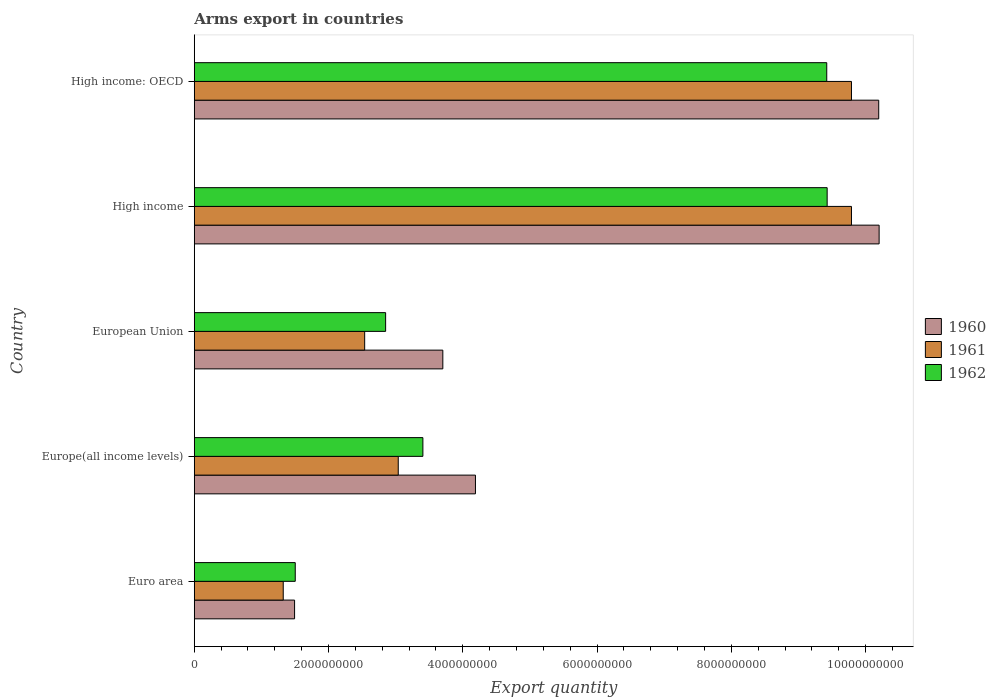How many groups of bars are there?
Your response must be concise. 5. In how many cases, is the number of bars for a given country not equal to the number of legend labels?
Make the answer very short. 0. What is the total arms export in 1961 in Euro area?
Offer a terse response. 1.32e+09. Across all countries, what is the maximum total arms export in 1962?
Provide a short and direct response. 9.43e+09. Across all countries, what is the minimum total arms export in 1962?
Keep it short and to the point. 1.50e+09. In which country was the total arms export in 1962 maximum?
Your answer should be very brief. High income. What is the total total arms export in 1962 in the graph?
Provide a succinct answer. 2.66e+1. What is the difference between the total arms export in 1961 in Europe(all income levels) and that in High income?
Make the answer very short. -6.75e+09. What is the difference between the total arms export in 1961 in High income: OECD and the total arms export in 1960 in Europe(all income levels)?
Give a very brief answer. 5.60e+09. What is the average total arms export in 1960 per country?
Your response must be concise. 5.96e+09. What is the difference between the total arms export in 1960 and total arms export in 1962 in European Union?
Offer a terse response. 8.52e+08. What is the ratio of the total arms export in 1962 in Euro area to that in Europe(all income levels)?
Give a very brief answer. 0.44. What is the difference between the highest and the lowest total arms export in 1962?
Your answer should be very brief. 7.92e+09. In how many countries, is the total arms export in 1962 greater than the average total arms export in 1962 taken over all countries?
Offer a terse response. 2. How many bars are there?
Ensure brevity in your answer.  15. Are the values on the major ticks of X-axis written in scientific E-notation?
Provide a short and direct response. No. Does the graph contain grids?
Provide a succinct answer. No. What is the title of the graph?
Make the answer very short. Arms export in countries. What is the label or title of the X-axis?
Provide a short and direct response. Export quantity. What is the label or title of the Y-axis?
Your answer should be very brief. Country. What is the Export quantity of 1960 in Euro area?
Your answer should be compact. 1.49e+09. What is the Export quantity in 1961 in Euro area?
Your answer should be very brief. 1.32e+09. What is the Export quantity in 1962 in Euro area?
Offer a terse response. 1.50e+09. What is the Export quantity in 1960 in Europe(all income levels)?
Provide a succinct answer. 4.19e+09. What is the Export quantity in 1961 in Europe(all income levels)?
Give a very brief answer. 3.04e+09. What is the Export quantity in 1962 in Europe(all income levels)?
Offer a terse response. 3.40e+09. What is the Export quantity in 1960 in European Union?
Provide a succinct answer. 3.70e+09. What is the Export quantity of 1961 in European Union?
Your response must be concise. 2.54e+09. What is the Export quantity of 1962 in European Union?
Give a very brief answer. 2.85e+09. What is the Export quantity of 1960 in High income?
Give a very brief answer. 1.02e+1. What is the Export quantity of 1961 in High income?
Provide a short and direct response. 9.79e+09. What is the Export quantity of 1962 in High income?
Make the answer very short. 9.43e+09. What is the Export quantity in 1960 in High income: OECD?
Your answer should be very brief. 1.02e+1. What is the Export quantity of 1961 in High income: OECD?
Keep it short and to the point. 9.79e+09. What is the Export quantity in 1962 in High income: OECD?
Make the answer very short. 9.42e+09. Across all countries, what is the maximum Export quantity of 1960?
Make the answer very short. 1.02e+1. Across all countries, what is the maximum Export quantity of 1961?
Make the answer very short. 9.79e+09. Across all countries, what is the maximum Export quantity in 1962?
Your response must be concise. 9.43e+09. Across all countries, what is the minimum Export quantity of 1960?
Make the answer very short. 1.49e+09. Across all countries, what is the minimum Export quantity of 1961?
Your response must be concise. 1.32e+09. Across all countries, what is the minimum Export quantity of 1962?
Provide a short and direct response. 1.50e+09. What is the total Export quantity of 1960 in the graph?
Offer a terse response. 2.98e+1. What is the total Export quantity of 1961 in the graph?
Provide a short and direct response. 2.65e+1. What is the total Export quantity in 1962 in the graph?
Offer a terse response. 2.66e+1. What is the difference between the Export quantity of 1960 in Euro area and that in Europe(all income levels)?
Make the answer very short. -2.69e+09. What is the difference between the Export quantity in 1961 in Euro area and that in Europe(all income levels)?
Give a very brief answer. -1.71e+09. What is the difference between the Export quantity of 1962 in Euro area and that in Europe(all income levels)?
Offer a terse response. -1.90e+09. What is the difference between the Export quantity in 1960 in Euro area and that in European Union?
Give a very brief answer. -2.21e+09. What is the difference between the Export quantity in 1961 in Euro area and that in European Union?
Ensure brevity in your answer.  -1.21e+09. What is the difference between the Export quantity of 1962 in Euro area and that in European Union?
Give a very brief answer. -1.35e+09. What is the difference between the Export quantity in 1960 in Euro area and that in High income?
Make the answer very short. -8.71e+09. What is the difference between the Export quantity of 1961 in Euro area and that in High income?
Your answer should be compact. -8.46e+09. What is the difference between the Export quantity in 1962 in Euro area and that in High income?
Your answer should be very brief. -7.92e+09. What is the difference between the Export quantity in 1960 in Euro area and that in High income: OECD?
Ensure brevity in your answer.  -8.70e+09. What is the difference between the Export quantity in 1961 in Euro area and that in High income: OECD?
Keep it short and to the point. -8.46e+09. What is the difference between the Export quantity in 1962 in Euro area and that in High income: OECD?
Your answer should be very brief. -7.92e+09. What is the difference between the Export quantity in 1960 in Europe(all income levels) and that in European Union?
Provide a short and direct response. 4.86e+08. What is the difference between the Export quantity in 1962 in Europe(all income levels) and that in European Union?
Your answer should be very brief. 5.55e+08. What is the difference between the Export quantity in 1960 in Europe(all income levels) and that in High income?
Your answer should be very brief. -6.01e+09. What is the difference between the Export quantity of 1961 in Europe(all income levels) and that in High income?
Your response must be concise. -6.75e+09. What is the difference between the Export quantity of 1962 in Europe(all income levels) and that in High income?
Make the answer very short. -6.02e+09. What is the difference between the Export quantity in 1960 in Europe(all income levels) and that in High income: OECD?
Make the answer very short. -6.01e+09. What is the difference between the Export quantity in 1961 in Europe(all income levels) and that in High income: OECD?
Offer a terse response. -6.75e+09. What is the difference between the Export quantity of 1962 in Europe(all income levels) and that in High income: OECD?
Offer a very short reply. -6.02e+09. What is the difference between the Export quantity of 1960 in European Union and that in High income?
Ensure brevity in your answer.  -6.50e+09. What is the difference between the Export quantity in 1961 in European Union and that in High income?
Make the answer very short. -7.25e+09. What is the difference between the Export quantity in 1962 in European Union and that in High income?
Ensure brevity in your answer.  -6.58e+09. What is the difference between the Export quantity of 1960 in European Union and that in High income: OECD?
Your answer should be very brief. -6.49e+09. What is the difference between the Export quantity of 1961 in European Union and that in High income: OECD?
Ensure brevity in your answer.  -7.25e+09. What is the difference between the Export quantity of 1962 in European Union and that in High income: OECD?
Provide a succinct answer. -6.57e+09. What is the difference between the Export quantity of 1961 in High income and that in High income: OECD?
Provide a short and direct response. 0. What is the difference between the Export quantity of 1962 in High income and that in High income: OECD?
Keep it short and to the point. 6.00e+06. What is the difference between the Export quantity in 1960 in Euro area and the Export quantity in 1961 in Europe(all income levels)?
Provide a short and direct response. -1.54e+09. What is the difference between the Export quantity of 1960 in Euro area and the Export quantity of 1962 in Europe(all income levels)?
Ensure brevity in your answer.  -1.91e+09. What is the difference between the Export quantity of 1961 in Euro area and the Export quantity of 1962 in Europe(all income levels)?
Offer a very short reply. -2.08e+09. What is the difference between the Export quantity in 1960 in Euro area and the Export quantity in 1961 in European Union?
Provide a succinct answer. -1.04e+09. What is the difference between the Export quantity of 1960 in Euro area and the Export quantity of 1962 in European Union?
Provide a short and direct response. -1.36e+09. What is the difference between the Export quantity in 1961 in Euro area and the Export quantity in 1962 in European Union?
Offer a very short reply. -1.52e+09. What is the difference between the Export quantity of 1960 in Euro area and the Export quantity of 1961 in High income?
Provide a short and direct response. -8.29e+09. What is the difference between the Export quantity of 1960 in Euro area and the Export quantity of 1962 in High income?
Provide a succinct answer. -7.93e+09. What is the difference between the Export quantity of 1961 in Euro area and the Export quantity of 1962 in High income?
Your answer should be compact. -8.10e+09. What is the difference between the Export quantity of 1960 in Euro area and the Export quantity of 1961 in High income: OECD?
Provide a short and direct response. -8.29e+09. What is the difference between the Export quantity in 1960 in Euro area and the Export quantity in 1962 in High income: OECD?
Keep it short and to the point. -7.93e+09. What is the difference between the Export quantity in 1961 in Euro area and the Export quantity in 1962 in High income: OECD?
Your answer should be very brief. -8.10e+09. What is the difference between the Export quantity in 1960 in Europe(all income levels) and the Export quantity in 1961 in European Union?
Your answer should be compact. 1.65e+09. What is the difference between the Export quantity in 1960 in Europe(all income levels) and the Export quantity in 1962 in European Union?
Provide a short and direct response. 1.34e+09. What is the difference between the Export quantity of 1961 in Europe(all income levels) and the Export quantity of 1962 in European Union?
Make the answer very short. 1.88e+08. What is the difference between the Export quantity of 1960 in Europe(all income levels) and the Export quantity of 1961 in High income?
Give a very brief answer. -5.60e+09. What is the difference between the Export quantity of 1960 in Europe(all income levels) and the Export quantity of 1962 in High income?
Keep it short and to the point. -5.24e+09. What is the difference between the Export quantity in 1961 in Europe(all income levels) and the Export quantity in 1962 in High income?
Ensure brevity in your answer.  -6.39e+09. What is the difference between the Export quantity of 1960 in Europe(all income levels) and the Export quantity of 1961 in High income: OECD?
Your answer should be compact. -5.60e+09. What is the difference between the Export quantity of 1960 in Europe(all income levels) and the Export quantity of 1962 in High income: OECD?
Keep it short and to the point. -5.23e+09. What is the difference between the Export quantity in 1961 in Europe(all income levels) and the Export quantity in 1962 in High income: OECD?
Offer a terse response. -6.38e+09. What is the difference between the Export quantity in 1960 in European Union and the Export quantity in 1961 in High income?
Offer a terse response. -6.09e+09. What is the difference between the Export quantity in 1960 in European Union and the Export quantity in 1962 in High income?
Offer a terse response. -5.72e+09. What is the difference between the Export quantity in 1961 in European Union and the Export quantity in 1962 in High income?
Ensure brevity in your answer.  -6.89e+09. What is the difference between the Export quantity of 1960 in European Union and the Export quantity of 1961 in High income: OECD?
Provide a succinct answer. -6.09e+09. What is the difference between the Export quantity in 1960 in European Union and the Export quantity in 1962 in High income: OECD?
Your response must be concise. -5.72e+09. What is the difference between the Export quantity of 1961 in European Union and the Export quantity of 1962 in High income: OECD?
Ensure brevity in your answer.  -6.88e+09. What is the difference between the Export quantity of 1960 in High income and the Export quantity of 1961 in High income: OECD?
Your answer should be very brief. 4.12e+08. What is the difference between the Export quantity in 1960 in High income and the Export quantity in 1962 in High income: OECD?
Provide a succinct answer. 7.80e+08. What is the difference between the Export quantity of 1961 in High income and the Export quantity of 1962 in High income: OECD?
Provide a succinct answer. 3.68e+08. What is the average Export quantity in 1960 per country?
Make the answer very short. 5.96e+09. What is the average Export quantity of 1961 per country?
Keep it short and to the point. 5.30e+09. What is the average Export quantity in 1962 per country?
Give a very brief answer. 5.32e+09. What is the difference between the Export quantity in 1960 and Export quantity in 1961 in Euro area?
Provide a short and direct response. 1.69e+08. What is the difference between the Export quantity of 1960 and Export quantity of 1962 in Euro area?
Provide a short and direct response. -1.00e+07. What is the difference between the Export quantity in 1961 and Export quantity in 1962 in Euro area?
Ensure brevity in your answer.  -1.79e+08. What is the difference between the Export quantity in 1960 and Export quantity in 1961 in Europe(all income levels)?
Keep it short and to the point. 1.15e+09. What is the difference between the Export quantity of 1960 and Export quantity of 1962 in Europe(all income levels)?
Your response must be concise. 7.83e+08. What is the difference between the Export quantity in 1961 and Export quantity in 1962 in Europe(all income levels)?
Provide a short and direct response. -3.67e+08. What is the difference between the Export quantity in 1960 and Export quantity in 1961 in European Union?
Keep it short and to the point. 1.16e+09. What is the difference between the Export quantity in 1960 and Export quantity in 1962 in European Union?
Your answer should be very brief. 8.52e+08. What is the difference between the Export quantity of 1961 and Export quantity of 1962 in European Union?
Your response must be concise. -3.12e+08. What is the difference between the Export quantity of 1960 and Export quantity of 1961 in High income?
Your answer should be very brief. 4.12e+08. What is the difference between the Export quantity in 1960 and Export quantity in 1962 in High income?
Offer a terse response. 7.74e+08. What is the difference between the Export quantity in 1961 and Export quantity in 1962 in High income?
Give a very brief answer. 3.62e+08. What is the difference between the Export quantity in 1960 and Export quantity in 1961 in High income: OECD?
Provide a short and direct response. 4.06e+08. What is the difference between the Export quantity in 1960 and Export quantity in 1962 in High income: OECD?
Ensure brevity in your answer.  7.74e+08. What is the difference between the Export quantity of 1961 and Export quantity of 1962 in High income: OECD?
Make the answer very short. 3.68e+08. What is the ratio of the Export quantity of 1960 in Euro area to that in Europe(all income levels)?
Provide a short and direct response. 0.36. What is the ratio of the Export quantity in 1961 in Euro area to that in Europe(all income levels)?
Make the answer very short. 0.44. What is the ratio of the Export quantity of 1962 in Euro area to that in Europe(all income levels)?
Offer a terse response. 0.44. What is the ratio of the Export quantity of 1960 in Euro area to that in European Union?
Your answer should be very brief. 0.4. What is the ratio of the Export quantity in 1961 in Euro area to that in European Union?
Ensure brevity in your answer.  0.52. What is the ratio of the Export quantity of 1962 in Euro area to that in European Union?
Your answer should be compact. 0.53. What is the ratio of the Export quantity of 1960 in Euro area to that in High income?
Offer a terse response. 0.15. What is the ratio of the Export quantity of 1961 in Euro area to that in High income?
Give a very brief answer. 0.14. What is the ratio of the Export quantity in 1962 in Euro area to that in High income?
Offer a terse response. 0.16. What is the ratio of the Export quantity of 1960 in Euro area to that in High income: OECD?
Provide a succinct answer. 0.15. What is the ratio of the Export quantity in 1961 in Euro area to that in High income: OECD?
Your answer should be compact. 0.14. What is the ratio of the Export quantity of 1962 in Euro area to that in High income: OECD?
Ensure brevity in your answer.  0.16. What is the ratio of the Export quantity in 1960 in Europe(all income levels) to that in European Union?
Give a very brief answer. 1.13. What is the ratio of the Export quantity of 1961 in Europe(all income levels) to that in European Union?
Your answer should be compact. 1.2. What is the ratio of the Export quantity of 1962 in Europe(all income levels) to that in European Union?
Give a very brief answer. 1.19. What is the ratio of the Export quantity in 1960 in Europe(all income levels) to that in High income?
Your response must be concise. 0.41. What is the ratio of the Export quantity in 1961 in Europe(all income levels) to that in High income?
Give a very brief answer. 0.31. What is the ratio of the Export quantity in 1962 in Europe(all income levels) to that in High income?
Make the answer very short. 0.36. What is the ratio of the Export quantity of 1960 in Europe(all income levels) to that in High income: OECD?
Give a very brief answer. 0.41. What is the ratio of the Export quantity in 1961 in Europe(all income levels) to that in High income: OECD?
Keep it short and to the point. 0.31. What is the ratio of the Export quantity of 1962 in Europe(all income levels) to that in High income: OECD?
Make the answer very short. 0.36. What is the ratio of the Export quantity in 1960 in European Union to that in High income?
Provide a short and direct response. 0.36. What is the ratio of the Export quantity of 1961 in European Union to that in High income?
Your answer should be compact. 0.26. What is the ratio of the Export quantity in 1962 in European Union to that in High income?
Offer a terse response. 0.3. What is the ratio of the Export quantity in 1960 in European Union to that in High income: OECD?
Your response must be concise. 0.36. What is the ratio of the Export quantity of 1961 in European Union to that in High income: OECD?
Offer a terse response. 0.26. What is the ratio of the Export quantity in 1962 in European Union to that in High income: OECD?
Your response must be concise. 0.3. What is the ratio of the Export quantity in 1960 in High income to that in High income: OECD?
Make the answer very short. 1. What is the difference between the highest and the lowest Export quantity of 1960?
Make the answer very short. 8.71e+09. What is the difference between the highest and the lowest Export quantity in 1961?
Your answer should be compact. 8.46e+09. What is the difference between the highest and the lowest Export quantity of 1962?
Your answer should be very brief. 7.92e+09. 